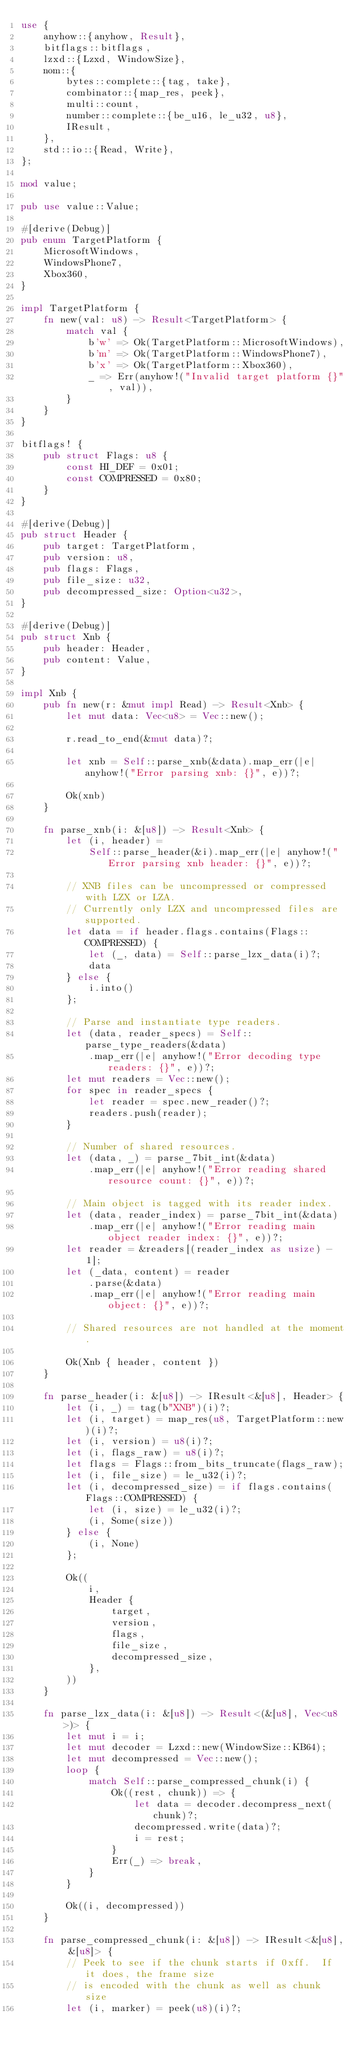<code> <loc_0><loc_0><loc_500><loc_500><_Rust_>use {
    anyhow::{anyhow, Result},
    bitflags::bitflags,
    lzxd::{Lzxd, WindowSize},
    nom::{
        bytes::complete::{tag, take},
        combinator::{map_res, peek},
        multi::count,
        number::complete::{be_u16, le_u32, u8},
        IResult,
    },
    std::io::{Read, Write},
};

mod value;

pub use value::Value;

#[derive(Debug)]
pub enum TargetPlatform {
    MicrosoftWindows,
    WindowsPhone7,
    Xbox360,
}

impl TargetPlatform {
    fn new(val: u8) -> Result<TargetPlatform> {
        match val {
            b'w' => Ok(TargetPlatform::MicrosoftWindows),
            b'm' => Ok(TargetPlatform::WindowsPhone7),
            b'x' => Ok(TargetPlatform::Xbox360),
            _ => Err(anyhow!("Invalid target platform {}", val)),
        }
    }
}

bitflags! {
    pub struct Flags: u8 {
        const HI_DEF = 0x01;
        const COMPRESSED = 0x80;
    }
}

#[derive(Debug)]
pub struct Header {
    pub target: TargetPlatform,
    pub version: u8,
    pub flags: Flags,
    pub file_size: u32,
    pub decompressed_size: Option<u32>,
}

#[derive(Debug)]
pub struct Xnb {
    pub header: Header,
    pub content: Value,
}

impl Xnb {
    pub fn new(r: &mut impl Read) -> Result<Xnb> {
        let mut data: Vec<u8> = Vec::new();

        r.read_to_end(&mut data)?;

        let xnb = Self::parse_xnb(&data).map_err(|e| anyhow!("Error parsing xnb: {}", e))?;

        Ok(xnb)
    }

    fn parse_xnb(i: &[u8]) -> Result<Xnb> {
        let (i, header) =
            Self::parse_header(&i).map_err(|e| anyhow!("Error parsing xnb header: {}", e))?;

        // XNB files can be uncompressed or compressed with LZX or LZA.
        // Currently only LZX and uncompressed files are supported.
        let data = if header.flags.contains(Flags::COMPRESSED) {
            let (_, data) = Self::parse_lzx_data(i)?;
            data
        } else {
            i.into()
        };

        // Parse and instantiate type readers.
        let (data, reader_specs) = Self::parse_type_readers(&data)
            .map_err(|e| anyhow!("Error decoding type readers: {}", e))?;
        let mut readers = Vec::new();
        for spec in reader_specs {
            let reader = spec.new_reader()?;
            readers.push(reader);
        }

        // Number of shared resources.
        let (data, _) = parse_7bit_int(&data)
            .map_err(|e| anyhow!("Error reading shared resource count: {}", e))?;

        // Main object is tagged with its reader index.
        let (data, reader_index) = parse_7bit_int(&data)
            .map_err(|e| anyhow!("Error reading main object reader index: {}", e))?;
        let reader = &readers[(reader_index as usize) - 1];
        let (_data, content) = reader
            .parse(&data)
            .map_err(|e| anyhow!("Error reading main object: {}", e))?;

        // Shared resources are not handled at the moment.

        Ok(Xnb { header, content })
    }

    fn parse_header(i: &[u8]) -> IResult<&[u8], Header> {
        let (i, _) = tag(b"XNB")(i)?;
        let (i, target) = map_res(u8, TargetPlatform::new)(i)?;
        let (i, version) = u8(i)?;
        let (i, flags_raw) = u8(i)?;
        let flags = Flags::from_bits_truncate(flags_raw);
        let (i, file_size) = le_u32(i)?;
        let (i, decompressed_size) = if flags.contains(Flags::COMPRESSED) {
            let (i, size) = le_u32(i)?;
            (i, Some(size))
        } else {
            (i, None)
        };

        Ok((
            i,
            Header {
                target,
                version,
                flags,
                file_size,
                decompressed_size,
            },
        ))
    }

    fn parse_lzx_data(i: &[u8]) -> Result<(&[u8], Vec<u8>)> {
        let mut i = i;
        let mut decoder = Lzxd::new(WindowSize::KB64);
        let mut decompressed = Vec::new();
        loop {
            match Self::parse_compressed_chunk(i) {
                Ok((rest, chunk)) => {
                    let data = decoder.decompress_next(chunk)?;
                    decompressed.write(data)?;
                    i = rest;
                }
                Err(_) => break,
            }
        }

        Ok((i, decompressed))
    }

    fn parse_compressed_chunk(i: &[u8]) -> IResult<&[u8], &[u8]> {
        // Peek to see if the chunk starts if 0xff.  If it does, the frame size
        // is encoded with the chunk as well as chunk size
        let (i, marker) = peek(u8)(i)?;</code> 